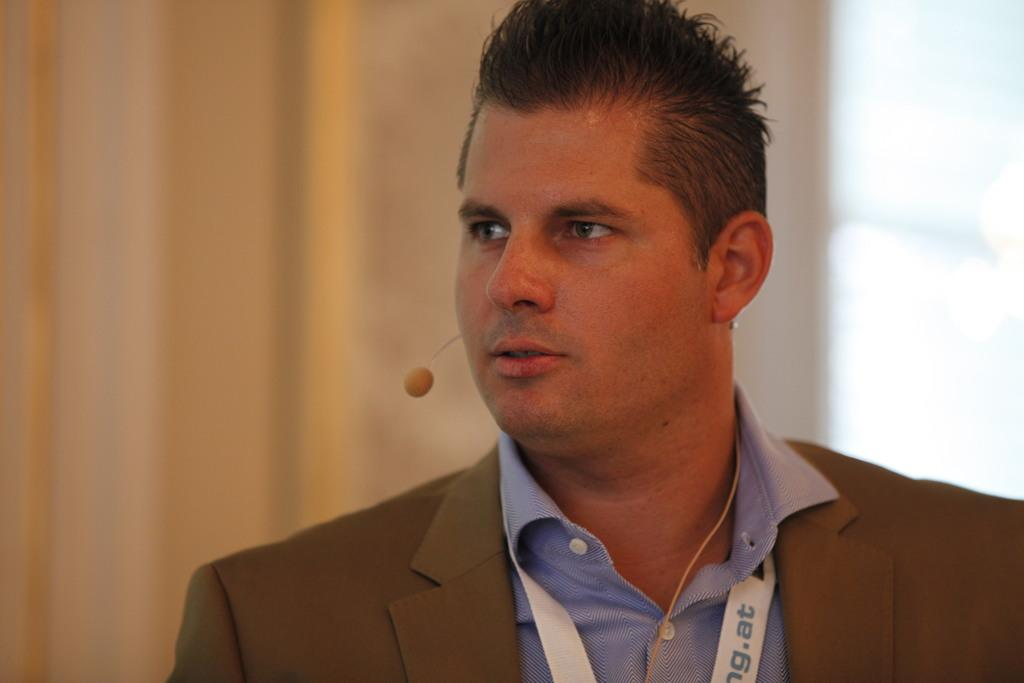What is the man in the image doing? The man is standing in the image. What type of clothing is the man wearing on his upper body? The man is wearing a blazer and a shirt. Can you describe any accessories the man is wearing? The man is wearing an ID card and a microphone. In which direction is the man looking? The man is looking to the left. How is the backdrop in the image? The backdrop is blurred. Can you see any jellyfish in the image? There are no jellyfish present in the image. What type of road is the man walking on in the image? The man is not walking in the image, and there is no road present. 